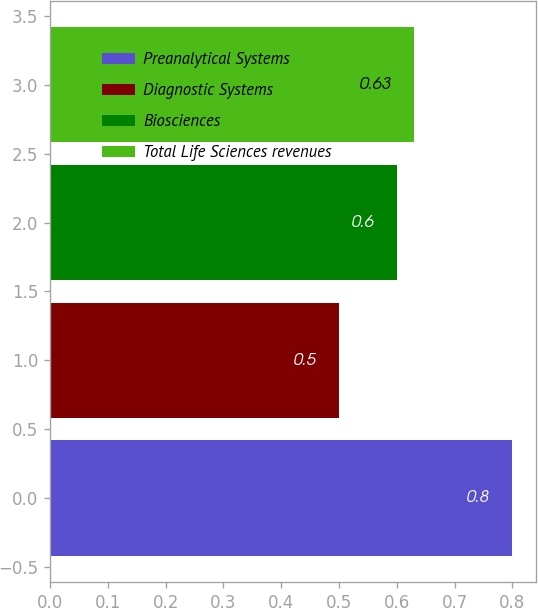Convert chart. <chart><loc_0><loc_0><loc_500><loc_500><bar_chart><fcel>Preanalytical Systems<fcel>Diagnostic Systems<fcel>Biosciences<fcel>Total Life Sciences revenues<nl><fcel>0.8<fcel>0.5<fcel>0.6<fcel>0.63<nl></chart> 